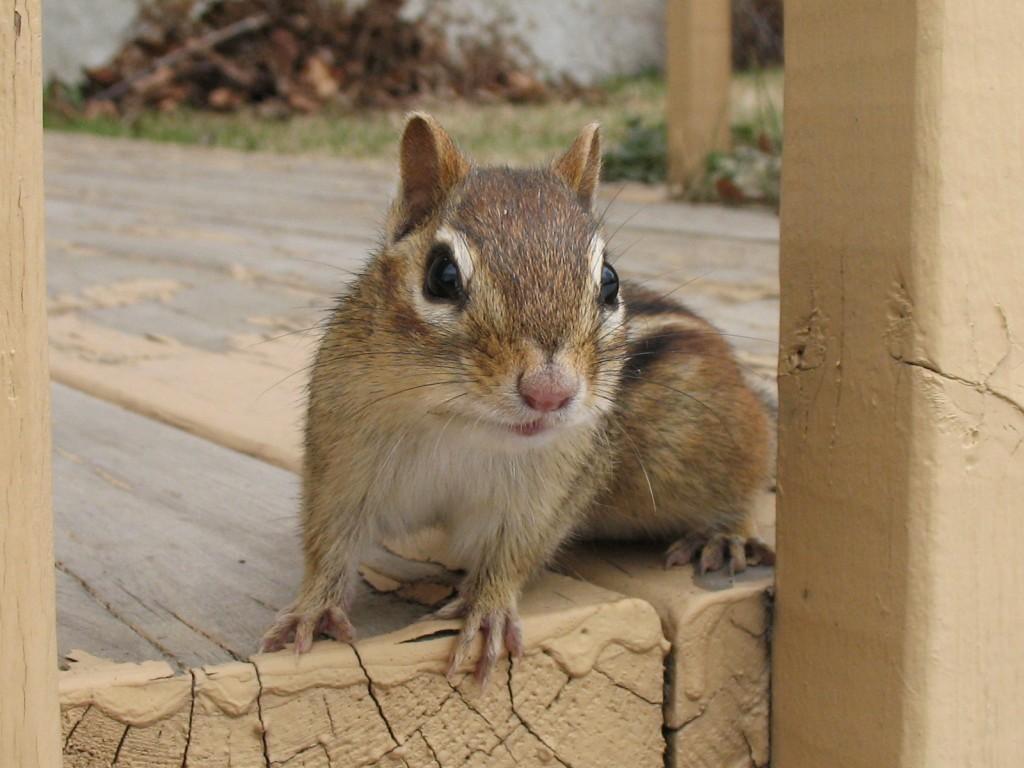In one or two sentences, can you explain what this image depicts? This image consists of a squirrel sitting on the floor. The floor is made up of wood. In the background, there are plants. To the left, there is a pillar. 